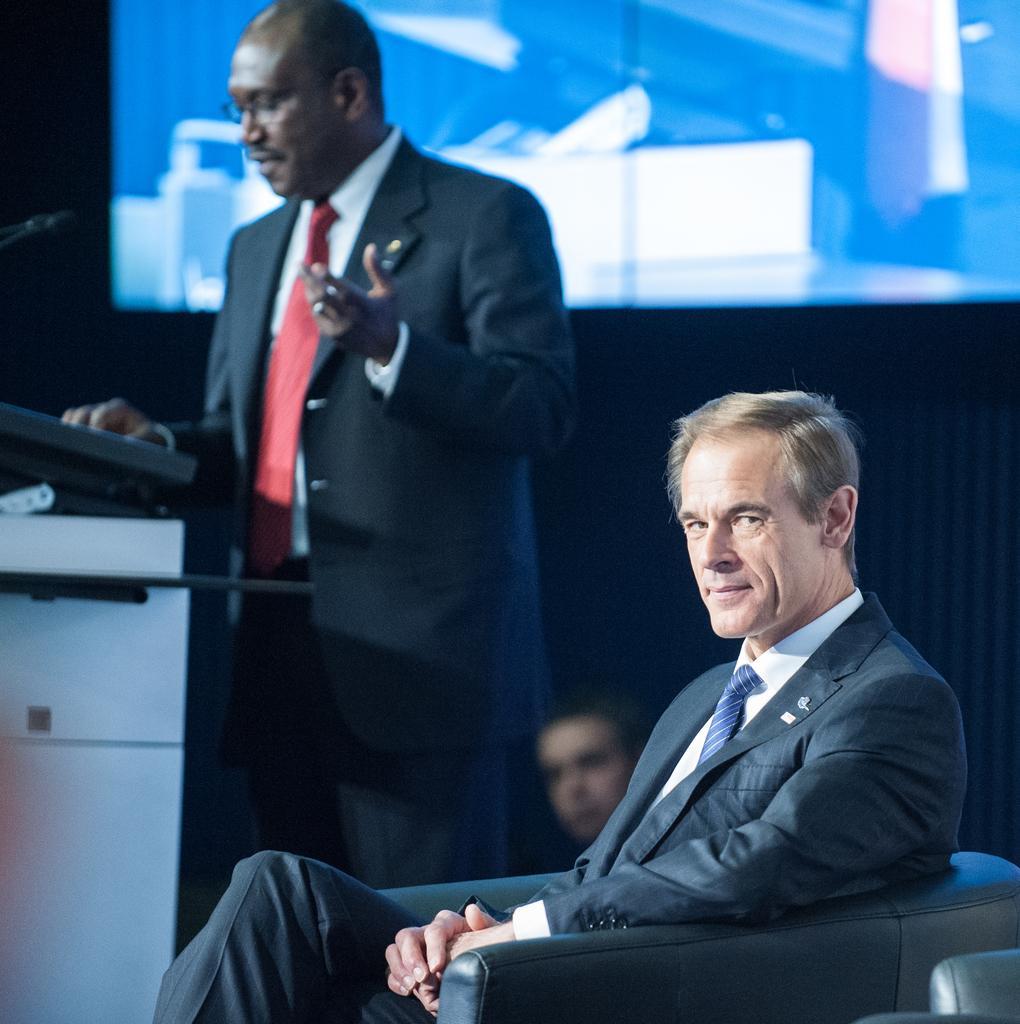Describe this image in one or two sentences. In this picture we can see few people and a man is sitting on the sofa chair, beside him we can see another man, he is standing, in the background we can see a screen. 